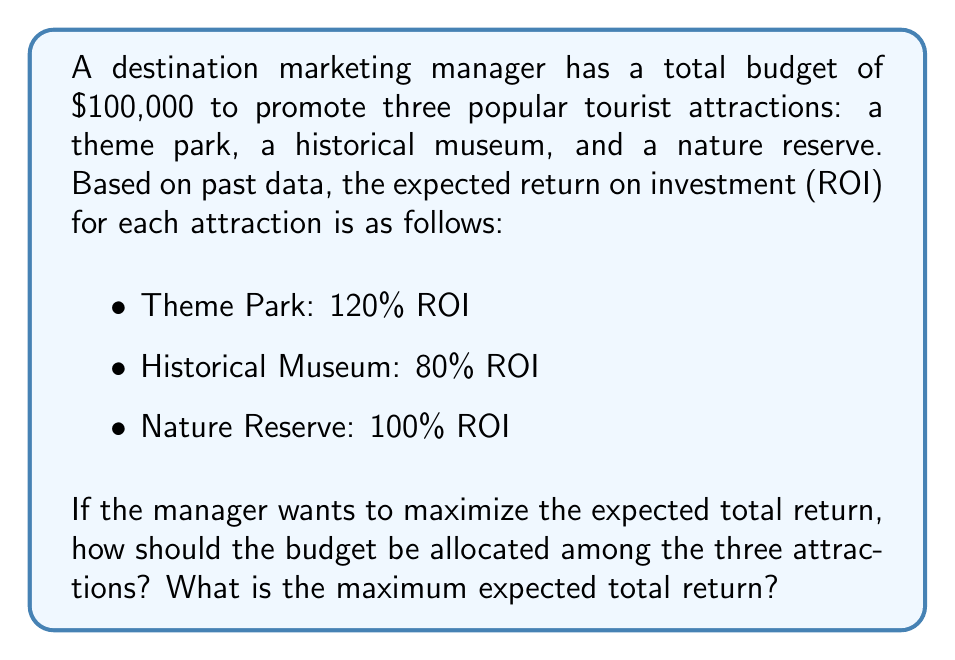Help me with this question. To solve this problem, we'll follow these steps:

1) First, we need to understand that to maximize the total return, we should allocate the entire budget to the attraction with the highest ROI.

2) The ROIs for each attraction are:
   - Theme Park: 120%
   - Historical Museum: 80%
   - Nature Reserve: 100%

3) The Theme Park has the highest ROI at 120%.

4) Therefore, the optimal allocation is to invest the entire $100,000 budget into promoting the Theme Park.

5) To calculate the expected total return:
   
   $$\text{Expected Return} = \text{Investment} \times (1 + \text{ROI})$$
   
   $$\text{Expected Return} = \$100,000 \times (1 + 1.20)$$
   
   $$\text{Expected Return} = \$100,000 \times 2.20 = \$220,000$$

6) The maximum expected total return is $220,000.
Answer: Allocate $100,000 to Theme Park; Expected return: $220,000 